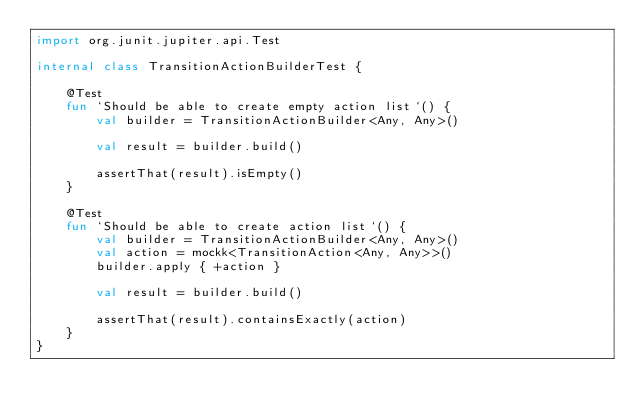<code> <loc_0><loc_0><loc_500><loc_500><_Kotlin_>import org.junit.jupiter.api.Test

internal class TransitionActionBuilderTest {

    @Test
    fun `Should be able to create empty action list`() {
        val builder = TransitionActionBuilder<Any, Any>()

        val result = builder.build()

        assertThat(result).isEmpty()
    }

    @Test
    fun `Should be able to create action list`() {
        val builder = TransitionActionBuilder<Any, Any>()
        val action = mockk<TransitionAction<Any, Any>>()
        builder.apply { +action }

        val result = builder.build()

        assertThat(result).containsExactly(action)
    }
}
</code> 